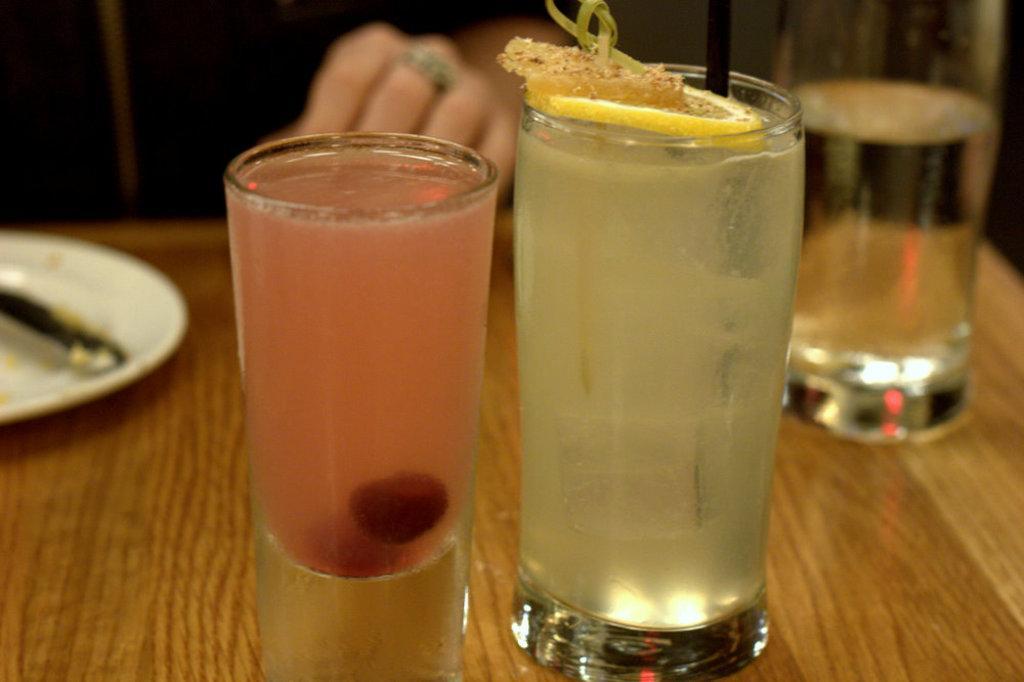Describe this image in one or two sentences. This picture shows few glasses and a plate on the table and we see a human seated. 